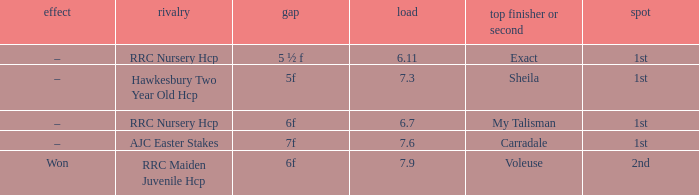What was the distance when the weight was 6.11? 5 ½ f. 